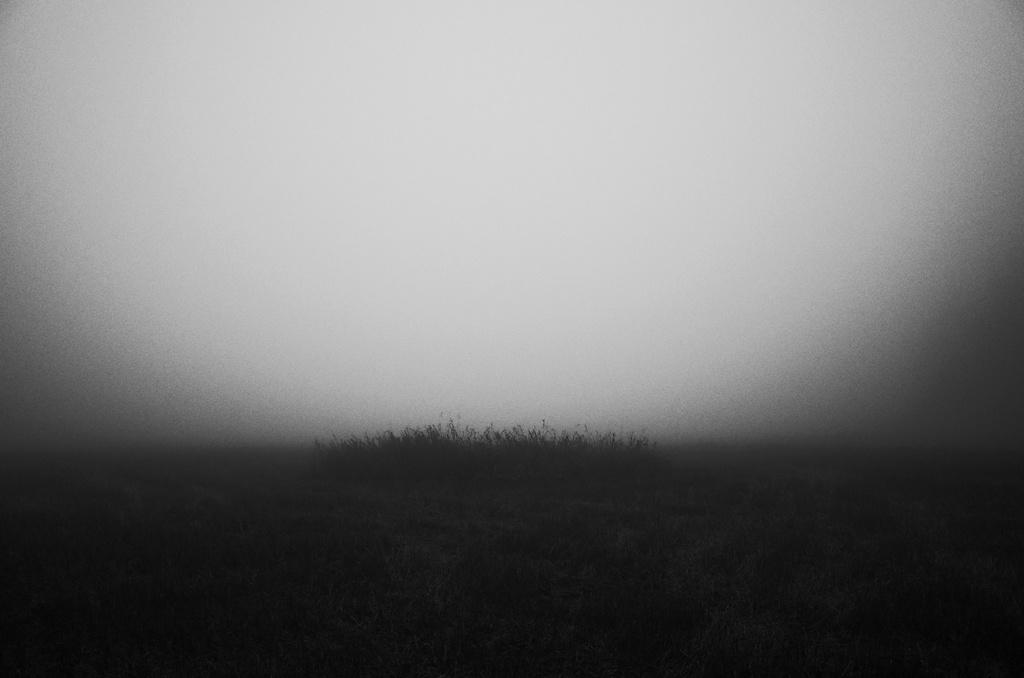What type of vegetation can be seen in the image? There are trees in the image. What part of the natural environment is visible in the image? The sky is visible in the image. Can you describe the time of day based on the image? The image may have been taken in the evening, as the sky appears to be darker. What type of trail can be seen in the image? There is no trail visible in the image; it only features trees and the sky. How many tickets are visible in the image? There are no tickets present in the image. 